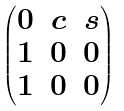<formula> <loc_0><loc_0><loc_500><loc_500>\begin{pmatrix} 0 & c & s \\ 1 & 0 & 0 \\ 1 & 0 & 0 \end{pmatrix}</formula> 